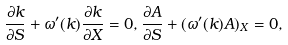<formula> <loc_0><loc_0><loc_500><loc_500>\frac { \partial k } { \partial S } + \omega ^ { \prime } ( k ) \frac { \partial k } { \partial X } = 0 , \frac { \partial A } { \partial S } + ( \omega ^ { \prime } ( k ) A ) _ { X } = 0 ,</formula> 